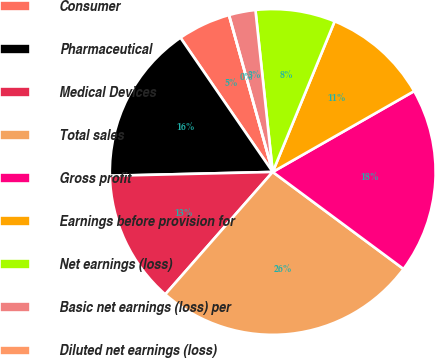Convert chart. <chart><loc_0><loc_0><loc_500><loc_500><pie_chart><fcel>Consumer<fcel>Pharmaceutical<fcel>Medical Devices<fcel>Total sales<fcel>Gross profit<fcel>Earnings before provision for<fcel>Net earnings (loss)<fcel>Basic net earnings (loss) per<fcel>Diluted net earnings (loss)<nl><fcel>5.26%<fcel>15.79%<fcel>13.16%<fcel>26.31%<fcel>18.42%<fcel>10.53%<fcel>7.9%<fcel>2.63%<fcel>0.0%<nl></chart> 